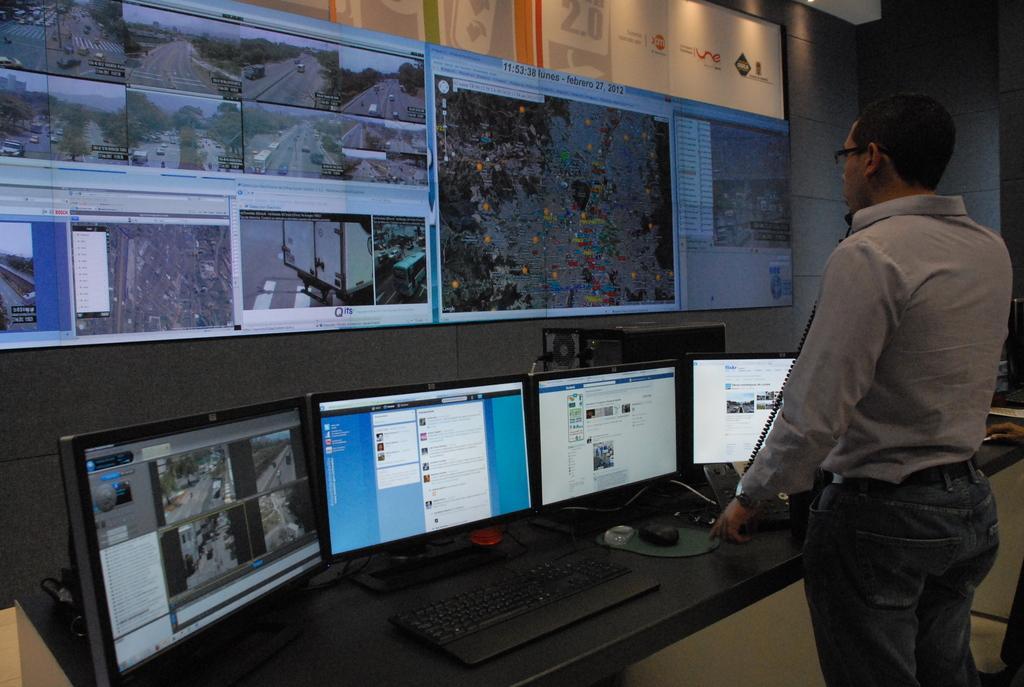Could you give a brief overview of what you see in this image? In this picture I can observe a person standing on the right side. He is wearing spectacles. In front of him there is a desk on which I can observe four monitors. There is a black color keyboard on the desk. In the background there is a screen. On the right I can observe a wall which is in grey color. 